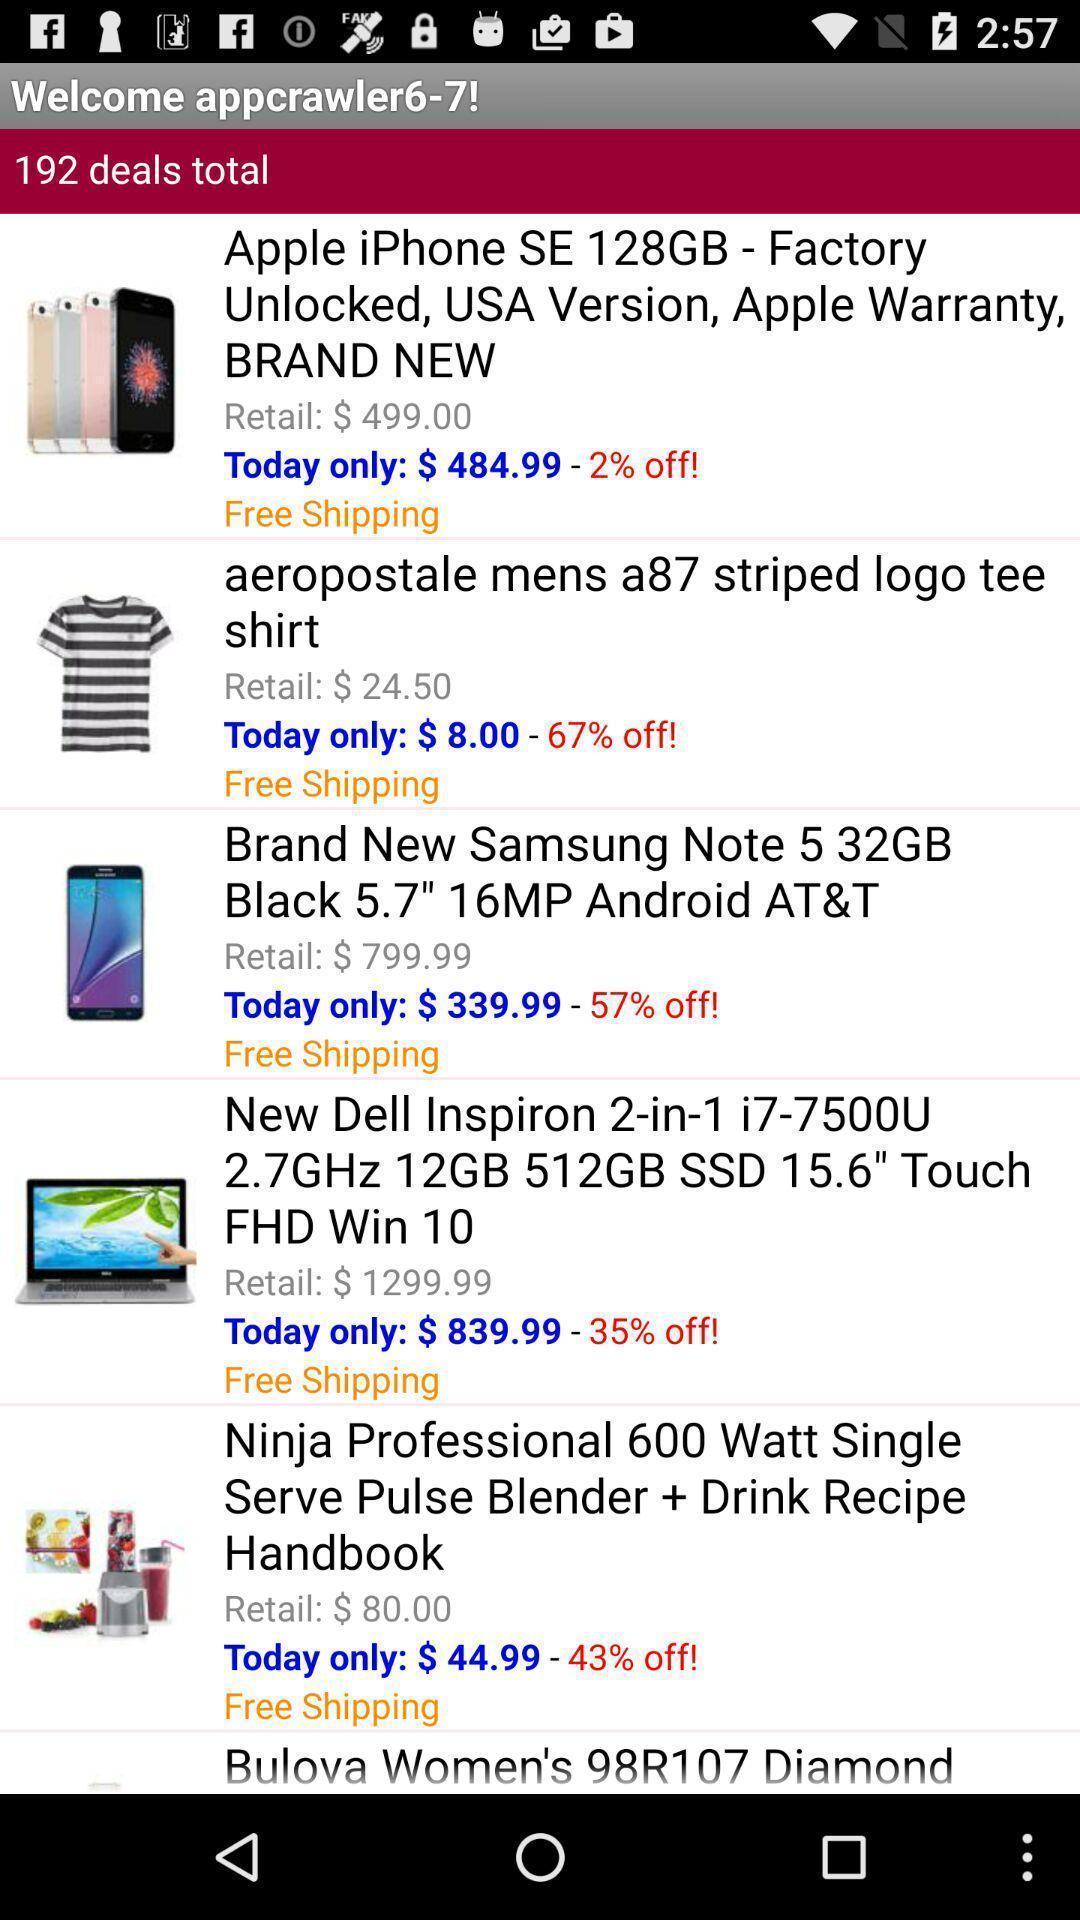What details can you identify in this image? Screen showing deals. 